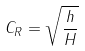<formula> <loc_0><loc_0><loc_500><loc_500>C _ { R } = \sqrt { \frac { h } { H } }</formula> 